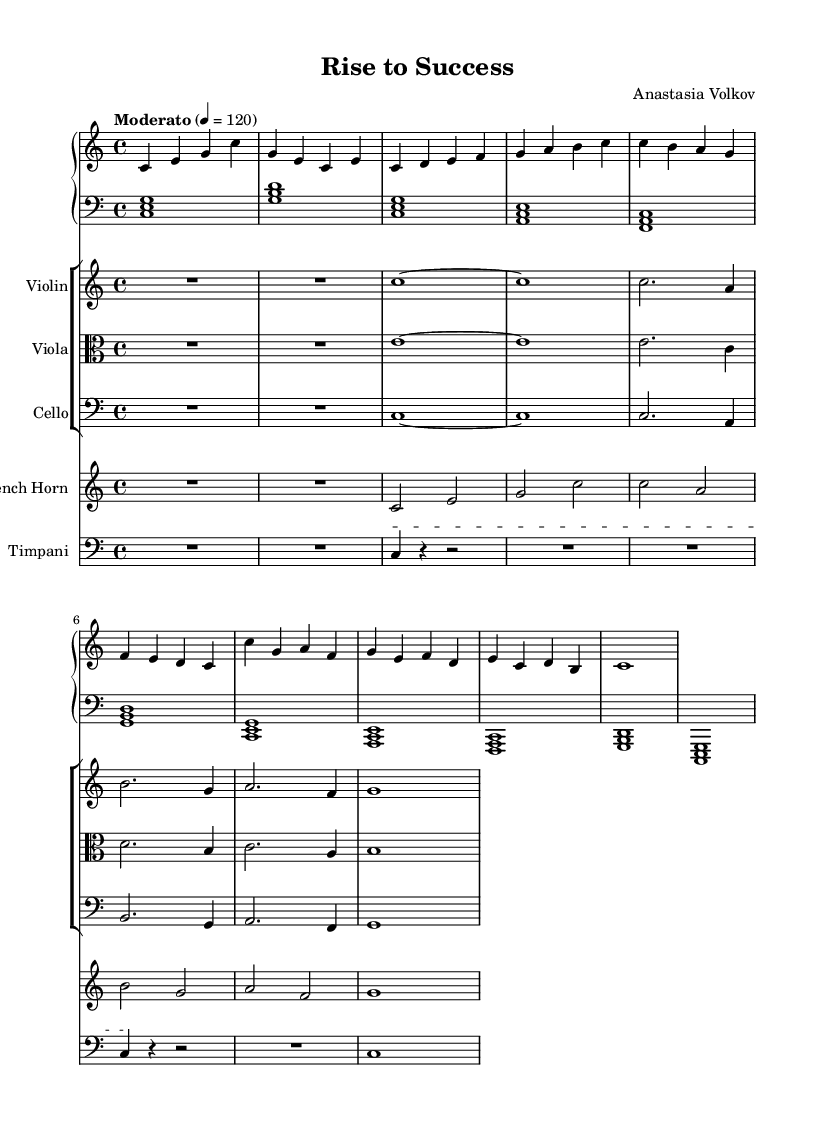What is the key signature of this music? The key signature is indicated at the beginning of the staff. In this case, it shows C major, which contains no sharps or flats.
Answer: C major What is the time signature of this music? The time signature is found at the beginning of the piece. Here, it shows 4/4, meaning there are four beats in a measure and a quarter note gets one beat.
Answer: 4/4 What tempo marking is used in this piece? The tempo marking indicates the speed of the piece. "Moderato" is marked at a quarter note equals 120 beats per minute, guiding the performers on how quickly to play.
Answer: Moderato, 120 How many measures are in the piano right-hand part? To find the number of measures, count the distinct groups of notes and symbols in the piano right-hand (RH) part. There are 8 measures present in that part.
Answer: 8 What instruments are included in this score? The score lists all instruments used in the piece. Upon examining the score, it reveals a piano (with both hands), violin, viola, cello, French horn, and timpani, totaling six instruments.
Answer: Piano, Violin, Viola, Cello, French Horn, Timpani Which section features a distinct rhythmic pattern with rests? The timpani staff indicates the distinct rhythmic pattern with rests, showcasing rests for emphasis and dynamics, particularly at the beginning and end of the part.
Answer: Timpani 